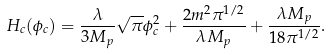Convert formula to latex. <formula><loc_0><loc_0><loc_500><loc_500>H _ { c } ( \phi _ { c } ) = \frac { \lambda } { 3 M _ { p } } \sqrt { \pi } \phi ^ { 2 } _ { c } + \frac { 2 m ^ { 2 } \pi ^ { 1 / 2 } } { \lambda M _ { p } } + \frac { \lambda M _ { p } } { 1 8 \pi ^ { 1 / 2 } } .</formula> 